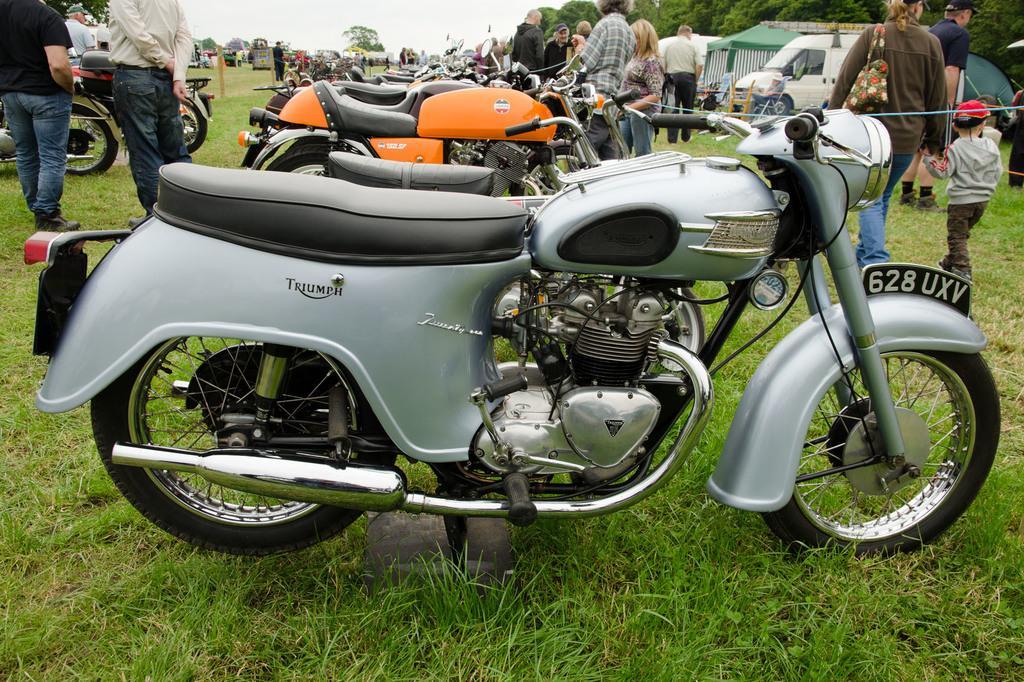Please provide a concise description of this image. There are bikes parked on the grass on the ground, near persons standing and near persons walking. In the background, there are vehicles, there are trees and there is sky 